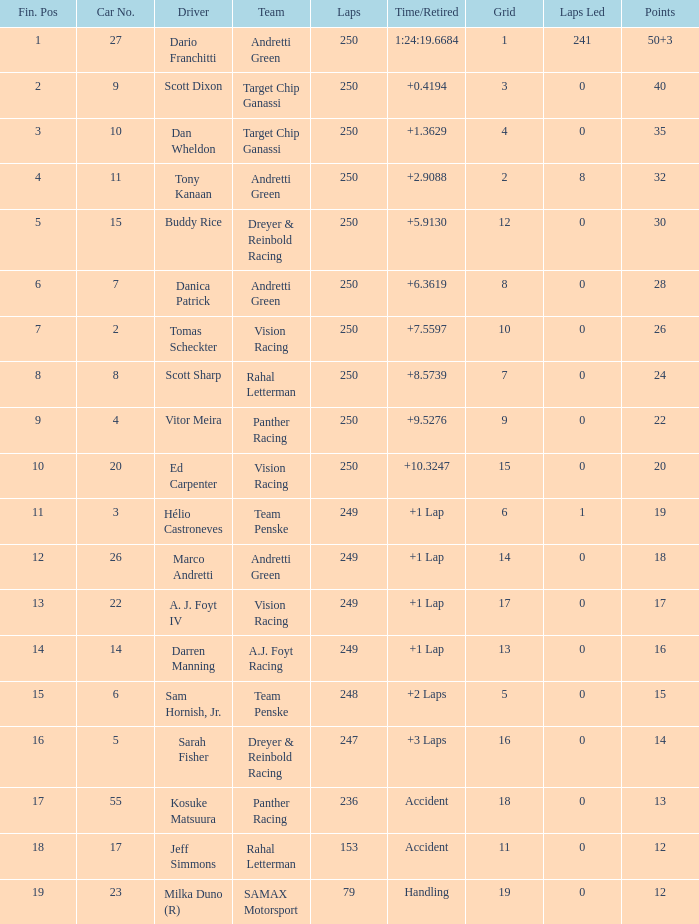Specify the amount of drivers for an economic status of 1 1.0. 